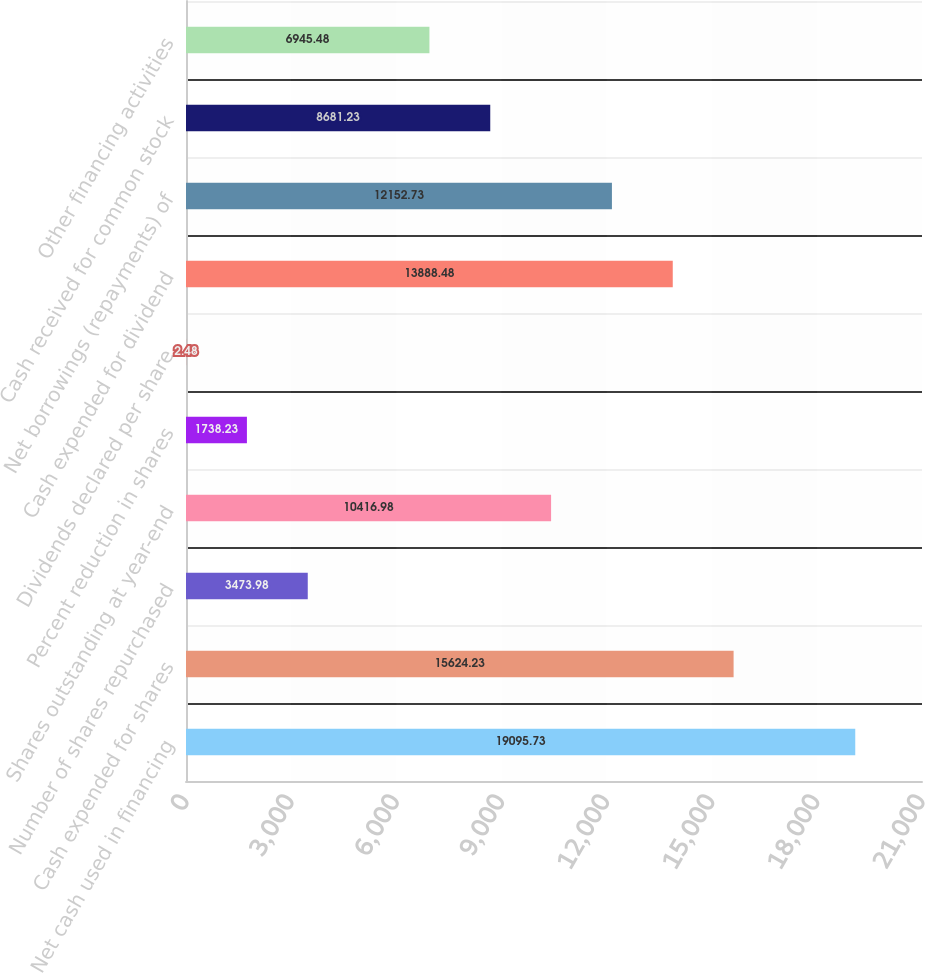Convert chart to OTSL. <chart><loc_0><loc_0><loc_500><loc_500><bar_chart><fcel>Net cash used in financing<fcel>Cash expended for shares<fcel>Number of shares repurchased<fcel>Shares outstanding at year-end<fcel>Percent reduction in shares<fcel>Dividends declared per share<fcel>Cash expended for dividend<fcel>Net borrowings (repayments) of<fcel>Cash received for common stock<fcel>Other financing activities<nl><fcel>19095.7<fcel>15624.2<fcel>3473.98<fcel>10417<fcel>1738.23<fcel>2.48<fcel>13888.5<fcel>12152.7<fcel>8681.23<fcel>6945.48<nl></chart> 